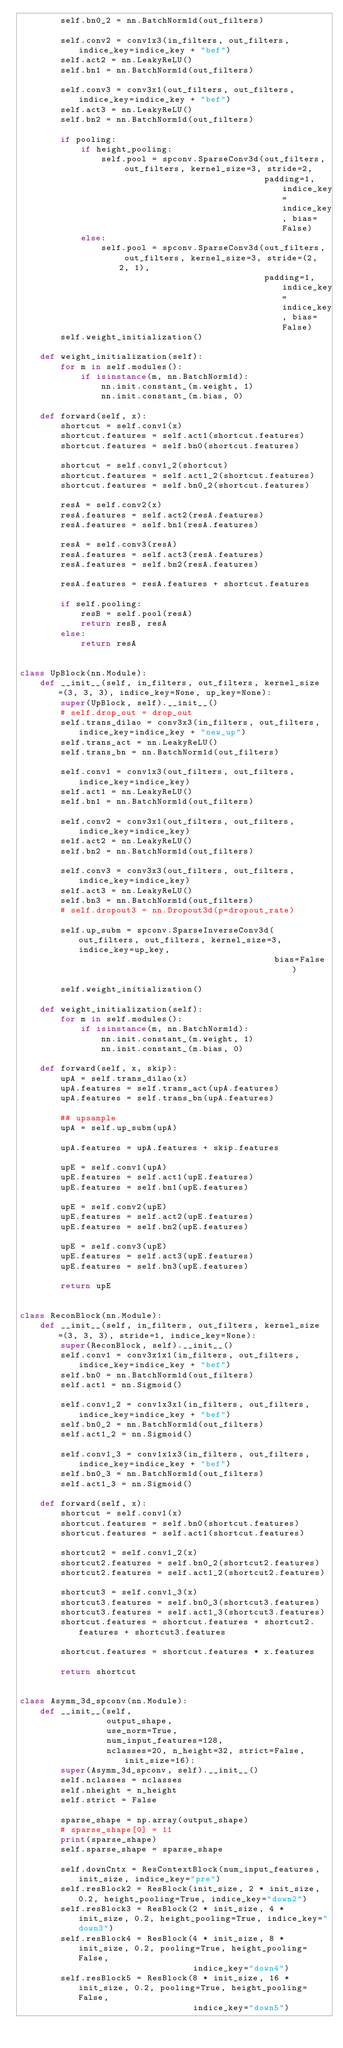<code> <loc_0><loc_0><loc_500><loc_500><_Python_>        self.bn0_2 = nn.BatchNorm1d(out_filters)

        self.conv2 = conv1x3(in_filters, out_filters, indice_key=indice_key + "bef")
        self.act2 = nn.LeakyReLU()
        self.bn1 = nn.BatchNorm1d(out_filters)

        self.conv3 = conv3x1(out_filters, out_filters, indice_key=indice_key + "bef")
        self.act3 = nn.LeakyReLU()
        self.bn2 = nn.BatchNorm1d(out_filters)

        if pooling:
            if height_pooling:
                self.pool = spconv.SparseConv3d(out_filters, out_filters, kernel_size=3, stride=2,
                                                padding=1, indice_key=indice_key, bias=False)
            else:
                self.pool = spconv.SparseConv3d(out_filters, out_filters, kernel_size=3, stride=(2, 2, 1),
                                                padding=1, indice_key=indice_key, bias=False)
        self.weight_initialization()

    def weight_initialization(self):
        for m in self.modules():
            if isinstance(m, nn.BatchNorm1d):
                nn.init.constant_(m.weight, 1)
                nn.init.constant_(m.bias, 0)

    def forward(self, x):
        shortcut = self.conv1(x)
        shortcut.features = self.act1(shortcut.features)
        shortcut.features = self.bn0(shortcut.features)

        shortcut = self.conv1_2(shortcut)
        shortcut.features = self.act1_2(shortcut.features)
        shortcut.features = self.bn0_2(shortcut.features)

        resA = self.conv2(x)
        resA.features = self.act2(resA.features)
        resA.features = self.bn1(resA.features)

        resA = self.conv3(resA)
        resA.features = self.act3(resA.features)
        resA.features = self.bn2(resA.features)

        resA.features = resA.features + shortcut.features

        if self.pooling:
            resB = self.pool(resA)
            return resB, resA
        else:
            return resA


class UpBlock(nn.Module):
    def __init__(self, in_filters, out_filters, kernel_size=(3, 3, 3), indice_key=None, up_key=None):
        super(UpBlock, self).__init__()
        # self.drop_out = drop_out
        self.trans_dilao = conv3x3(in_filters, out_filters, indice_key=indice_key + "new_up")
        self.trans_act = nn.LeakyReLU()
        self.trans_bn = nn.BatchNorm1d(out_filters)

        self.conv1 = conv1x3(out_filters, out_filters, indice_key=indice_key)
        self.act1 = nn.LeakyReLU()
        self.bn1 = nn.BatchNorm1d(out_filters)

        self.conv2 = conv3x1(out_filters, out_filters, indice_key=indice_key)
        self.act2 = nn.LeakyReLU()
        self.bn2 = nn.BatchNorm1d(out_filters)

        self.conv3 = conv3x3(out_filters, out_filters, indice_key=indice_key)
        self.act3 = nn.LeakyReLU()
        self.bn3 = nn.BatchNorm1d(out_filters)
        # self.dropout3 = nn.Dropout3d(p=dropout_rate)

        self.up_subm = spconv.SparseInverseConv3d(out_filters, out_filters, kernel_size=3, indice_key=up_key,
                                                  bias=False)

        self.weight_initialization()

    def weight_initialization(self):
        for m in self.modules():
            if isinstance(m, nn.BatchNorm1d):
                nn.init.constant_(m.weight, 1)
                nn.init.constant_(m.bias, 0)

    def forward(self, x, skip):
        upA = self.trans_dilao(x)
        upA.features = self.trans_act(upA.features)
        upA.features = self.trans_bn(upA.features)

        ## upsample
        upA = self.up_subm(upA)

        upA.features = upA.features + skip.features

        upE = self.conv1(upA)
        upE.features = self.act1(upE.features)
        upE.features = self.bn1(upE.features)

        upE = self.conv2(upE)
        upE.features = self.act2(upE.features)
        upE.features = self.bn2(upE.features)

        upE = self.conv3(upE)
        upE.features = self.act3(upE.features)
        upE.features = self.bn3(upE.features)

        return upE


class ReconBlock(nn.Module):
    def __init__(self, in_filters, out_filters, kernel_size=(3, 3, 3), stride=1, indice_key=None):
        super(ReconBlock, self).__init__()
        self.conv1 = conv3x1x1(in_filters, out_filters, indice_key=indice_key + "bef")
        self.bn0 = nn.BatchNorm1d(out_filters)
        self.act1 = nn.Sigmoid()

        self.conv1_2 = conv1x3x1(in_filters, out_filters, indice_key=indice_key + "bef")
        self.bn0_2 = nn.BatchNorm1d(out_filters)
        self.act1_2 = nn.Sigmoid()

        self.conv1_3 = conv1x1x3(in_filters, out_filters, indice_key=indice_key + "bef")
        self.bn0_3 = nn.BatchNorm1d(out_filters)
        self.act1_3 = nn.Sigmoid()

    def forward(self, x):
        shortcut = self.conv1(x)
        shortcut.features = self.bn0(shortcut.features)
        shortcut.features = self.act1(shortcut.features)

        shortcut2 = self.conv1_2(x)
        shortcut2.features = self.bn0_2(shortcut2.features)
        shortcut2.features = self.act1_2(shortcut2.features)

        shortcut3 = self.conv1_3(x)
        shortcut3.features = self.bn0_3(shortcut3.features)
        shortcut3.features = self.act1_3(shortcut3.features)
        shortcut.features = shortcut.features + shortcut2.features + shortcut3.features

        shortcut.features = shortcut.features * x.features

        return shortcut


class Asymm_3d_spconv(nn.Module):
    def __init__(self,
                 output_shape,
                 use_norm=True,
                 num_input_features=128,
                 nclasses=20, n_height=32, strict=False, init_size=16):
        super(Asymm_3d_spconv, self).__init__()
        self.nclasses = nclasses
        self.nheight = n_height
        self.strict = False

        sparse_shape = np.array(output_shape)
        # sparse_shape[0] = 11
        print(sparse_shape)
        self.sparse_shape = sparse_shape

        self.downCntx = ResContextBlock(num_input_features, init_size, indice_key="pre")
        self.resBlock2 = ResBlock(init_size, 2 * init_size, 0.2, height_pooling=True, indice_key="down2")
        self.resBlock3 = ResBlock(2 * init_size, 4 * init_size, 0.2, height_pooling=True, indice_key="down3")
        self.resBlock4 = ResBlock(4 * init_size, 8 * init_size, 0.2, pooling=True, height_pooling=False,
                                  indice_key="down4")
        self.resBlock5 = ResBlock(8 * init_size, 16 * init_size, 0.2, pooling=True, height_pooling=False,
                                  indice_key="down5")
</code> 